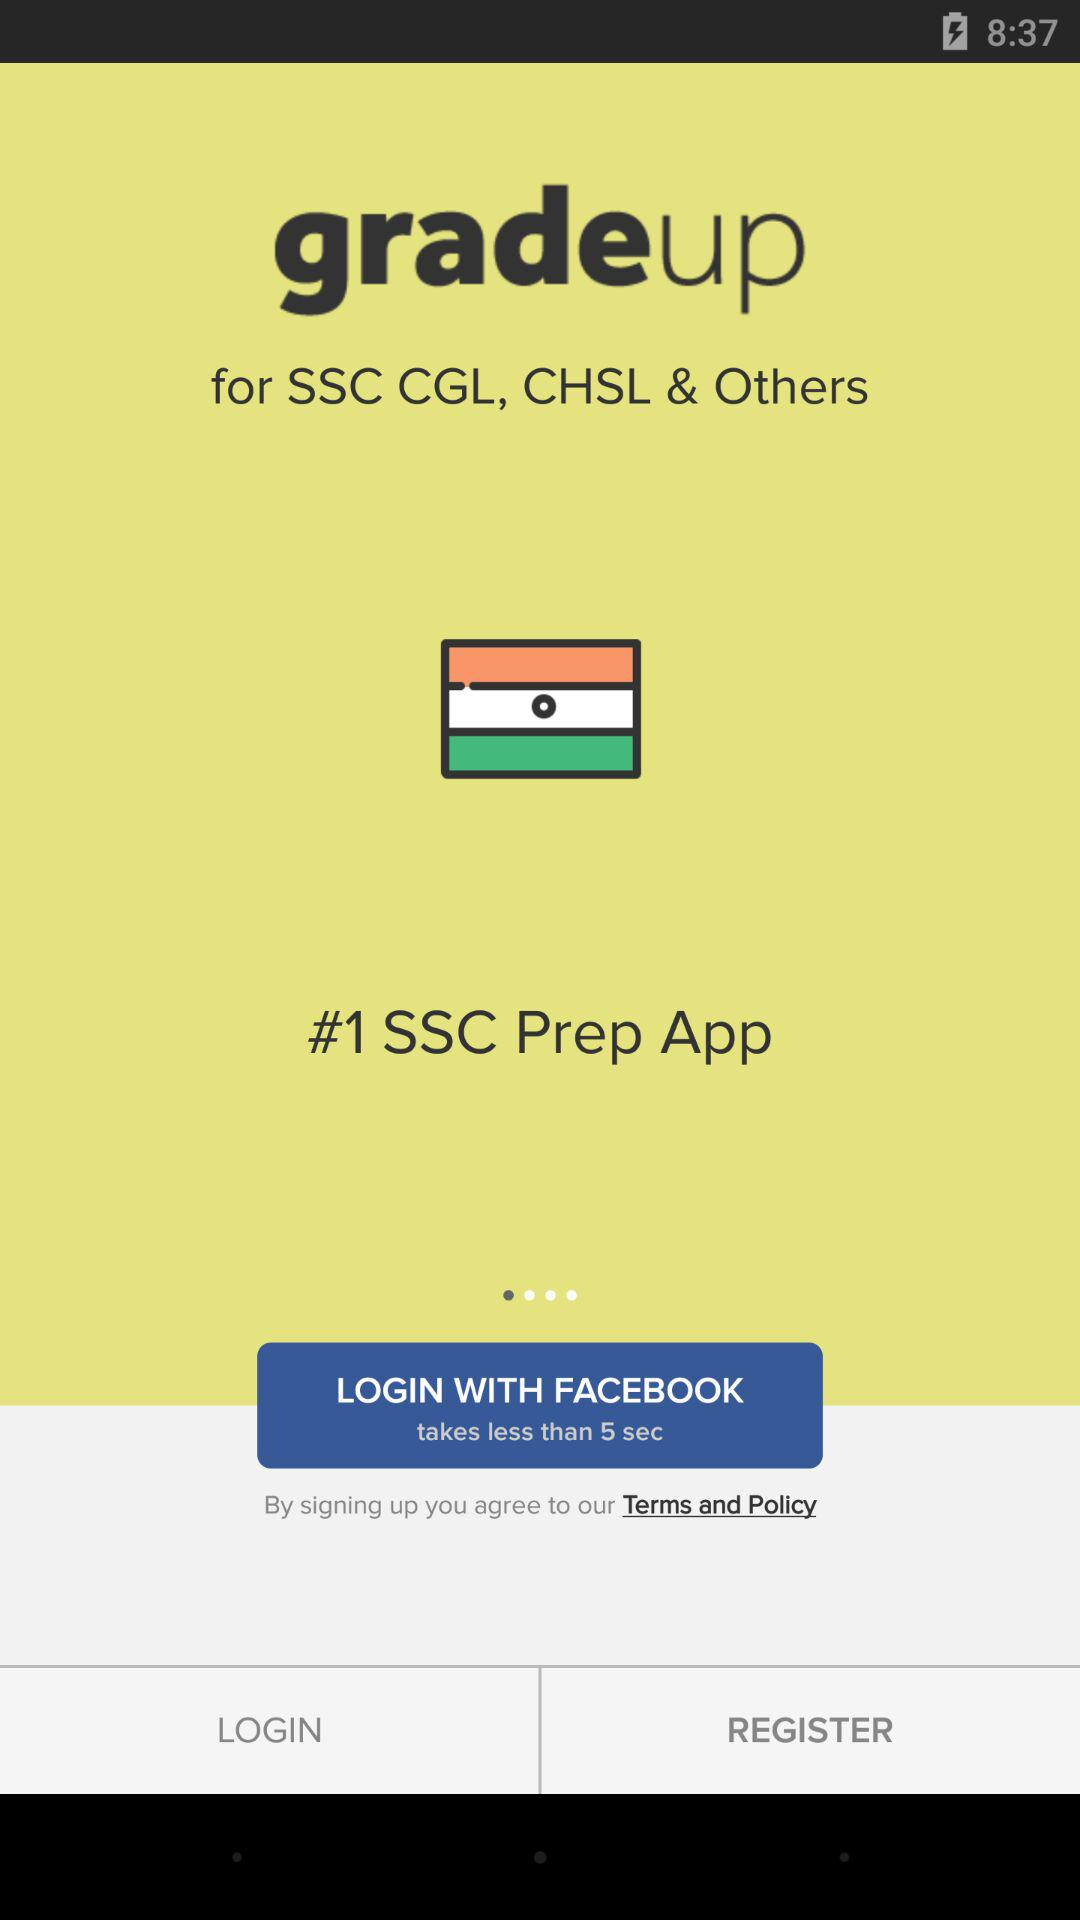What is the application name? The application name is "gradeup". 